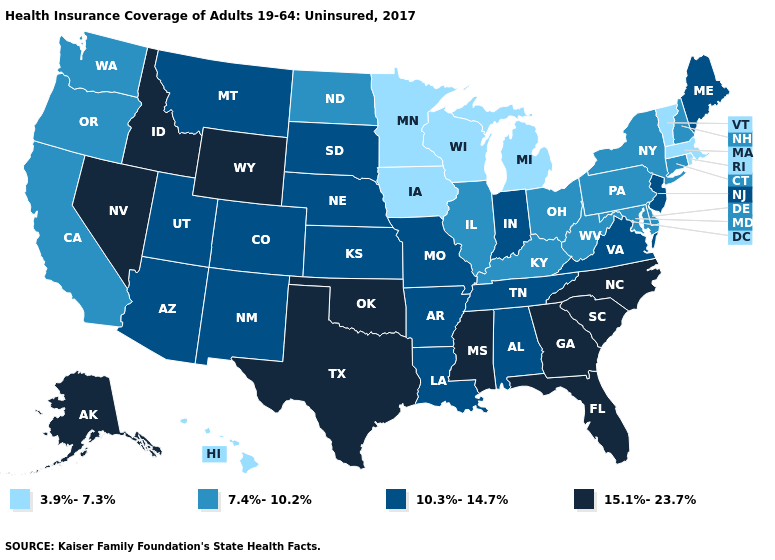Does North Carolina have a higher value than South Dakota?
Give a very brief answer. Yes. Name the states that have a value in the range 3.9%-7.3%?
Write a very short answer. Hawaii, Iowa, Massachusetts, Michigan, Minnesota, Rhode Island, Vermont, Wisconsin. Does Georgia have a higher value than Tennessee?
Keep it brief. Yes. What is the value of Louisiana?
Answer briefly. 10.3%-14.7%. What is the value of Nevada?
Keep it brief. 15.1%-23.7%. Does Louisiana have a higher value than Nebraska?
Write a very short answer. No. Name the states that have a value in the range 7.4%-10.2%?
Answer briefly. California, Connecticut, Delaware, Illinois, Kentucky, Maryland, New Hampshire, New York, North Dakota, Ohio, Oregon, Pennsylvania, Washington, West Virginia. Which states have the lowest value in the South?
Be succinct. Delaware, Kentucky, Maryland, West Virginia. Does the first symbol in the legend represent the smallest category?
Quick response, please. Yes. Does the first symbol in the legend represent the smallest category?
Concise answer only. Yes. What is the value of Rhode Island?
Answer briefly. 3.9%-7.3%. What is the value of Louisiana?
Write a very short answer. 10.3%-14.7%. Does Nevada have the highest value in the West?
Answer briefly. Yes. Does Pennsylvania have a lower value than Massachusetts?
Quick response, please. No. Does the map have missing data?
Write a very short answer. No. 